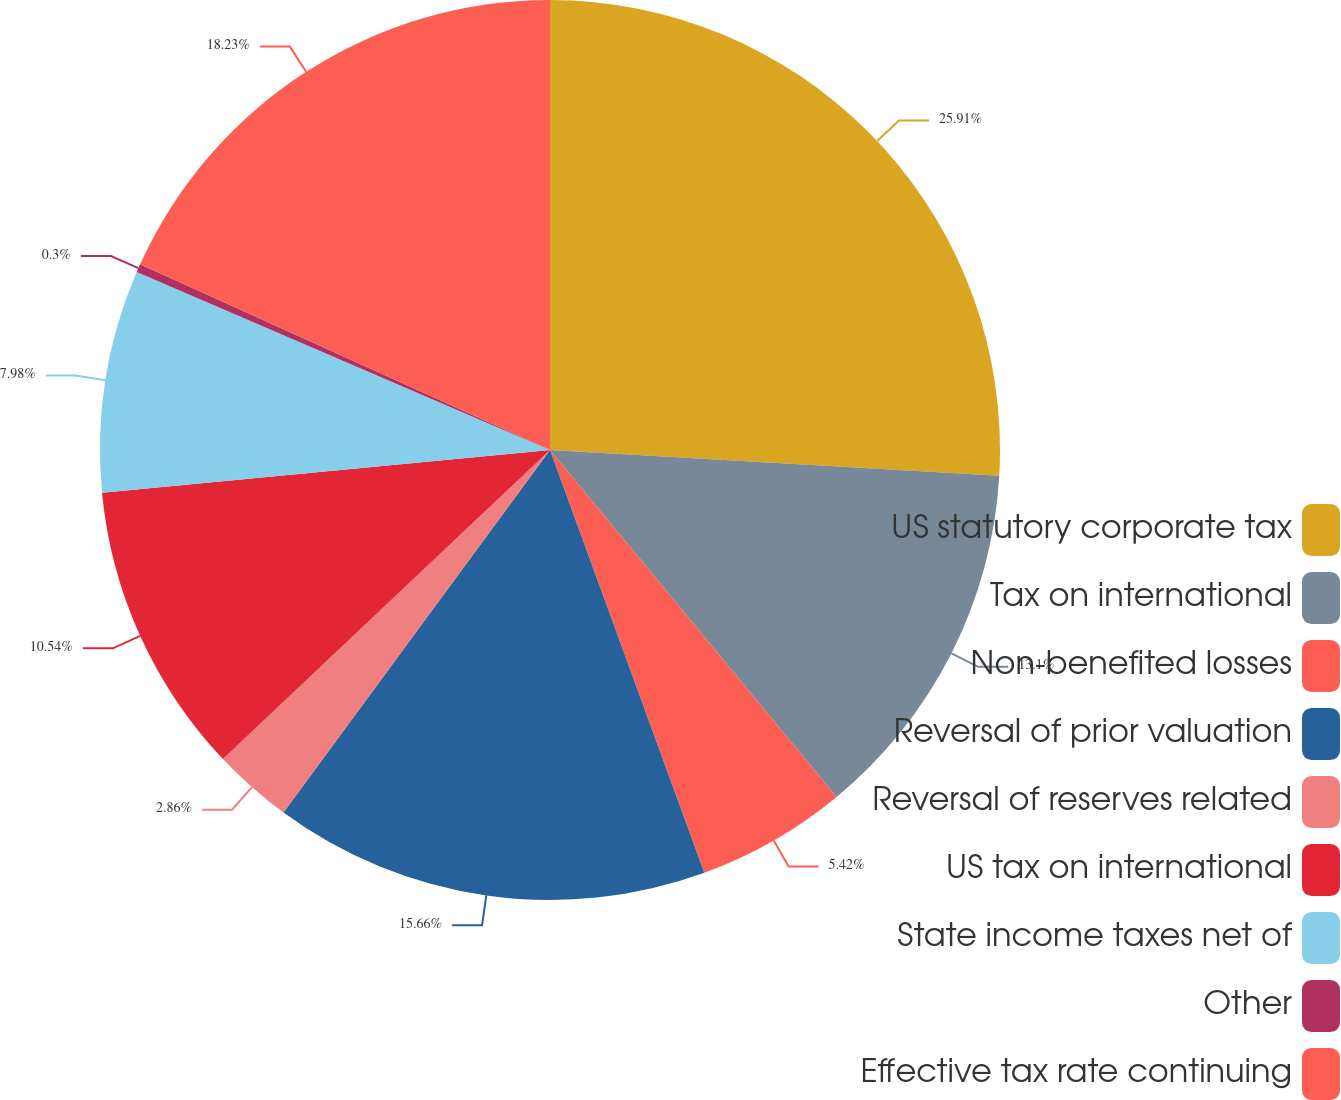Convert chart. <chart><loc_0><loc_0><loc_500><loc_500><pie_chart><fcel>US statutory corporate tax<fcel>Tax on international<fcel>Non-benefited losses<fcel>Reversal of prior valuation<fcel>Reversal of reserves related<fcel>US tax on international<fcel>State income taxes net of<fcel>Other<fcel>Effective tax rate continuing<nl><fcel>25.91%<fcel>13.1%<fcel>5.42%<fcel>15.66%<fcel>2.86%<fcel>10.54%<fcel>7.98%<fcel>0.3%<fcel>18.23%<nl></chart> 